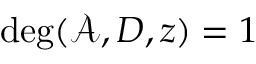<formula> <loc_0><loc_0><loc_500><loc_500>\deg ( \mathcal { A } , D , z ) = 1</formula> 